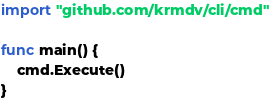Convert code to text. <code><loc_0><loc_0><loc_500><loc_500><_Go_>
import "github.com/krmdv/cli/cmd"

func main() {
	cmd.Execute()
}
</code> 